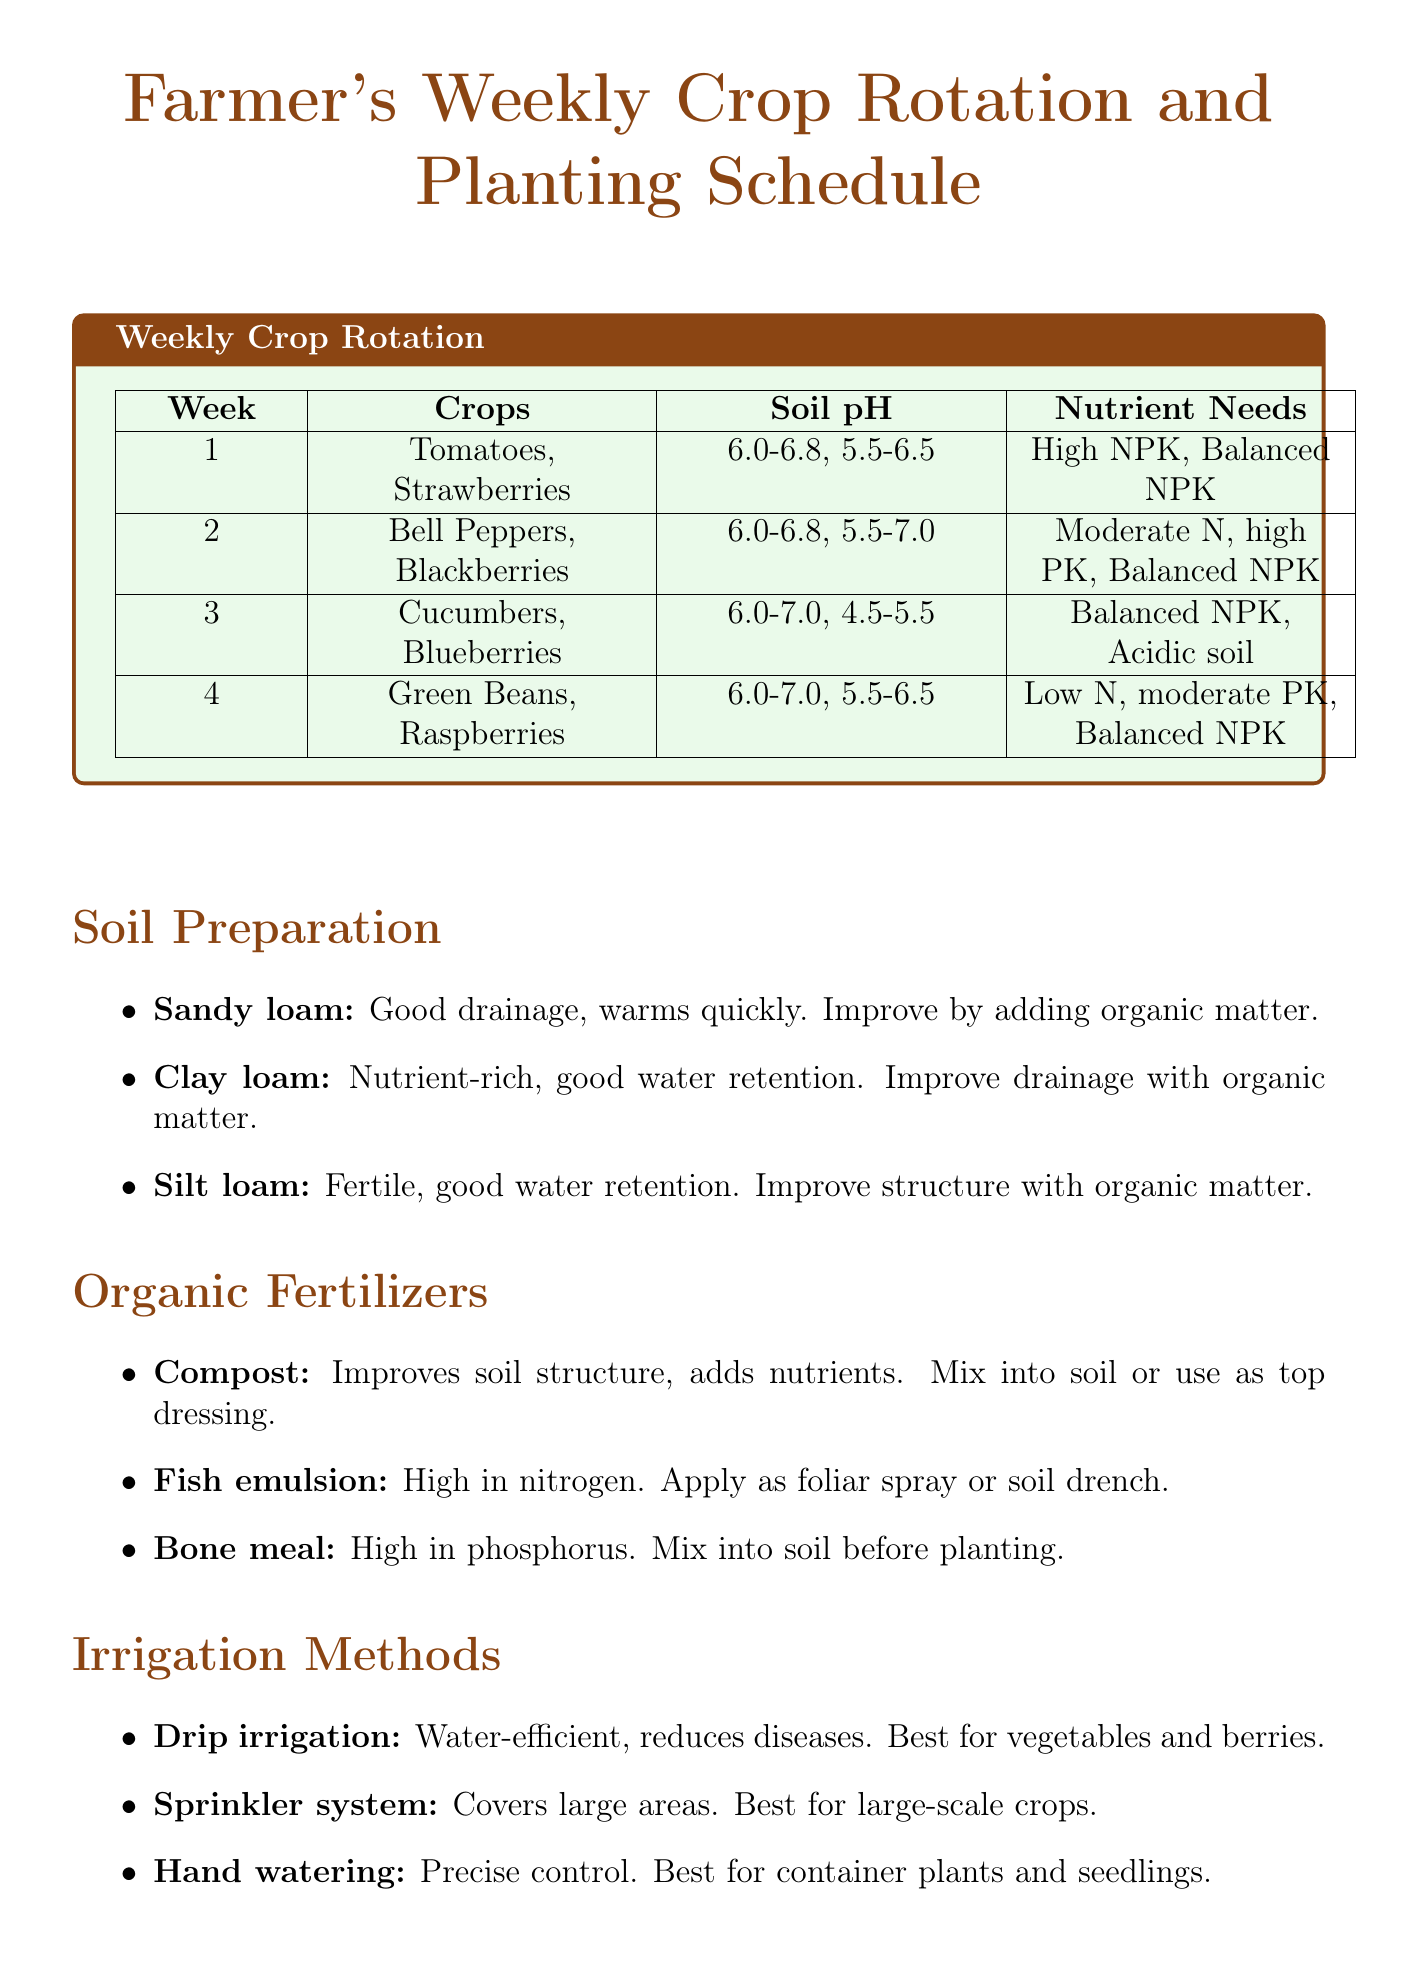What crops are planted in week 1? Week 1 includes Tomatoes and Strawberries as indicated in the crop rotation schedule.
Answer: Tomatoes, Strawberries What is the soil pH for Bell Peppers? The soil pH for Bell Peppers is mentioned as 6.0-6.8 in the document.
Answer: 6.0-6.8 Which organic fertilizer is high in nitrogen? The document states that Fish emulsion is high in nitrogen, making it suitable for leafy greens.
Answer: Fish emulsion What is the preferred irrigation method for vegetables? The document mentions Drip irrigation as the best method for vegetables due to its water efficiency.
Answer: Drip irrigation What companion plants are suggested for Raspberries? The document indicates that Garlic and Rue are recommended as companion plants for Raspberries.
Answer: Garlic, Rue How many weeks does the crop rotation schedule cover? The crop rotation schedule explicitly covers a total of 4 weeks.
Answer: 4 What are the benefits of sandy loam soil? The document lists good drainage and quick warming in spring as benefits of sandy loam soil.
Answer: Good drainage, warms quickly What pest is controlled by introducing ladybugs? The document states that ladybugs can be introduced to control Aphids.
Answer: Aphids 